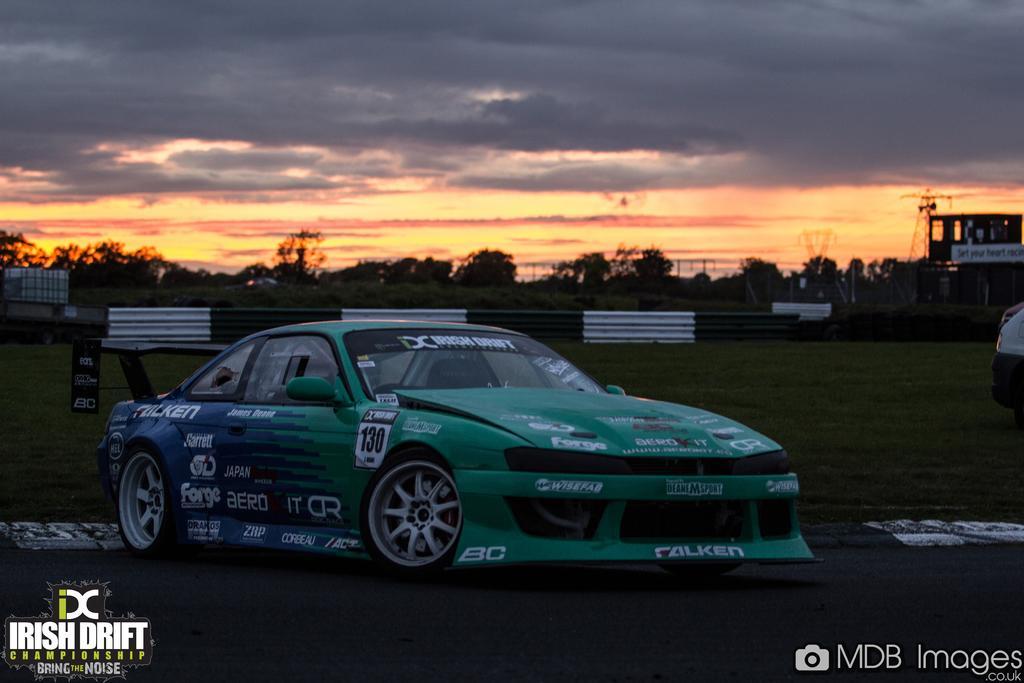Can you describe this image briefly? As we can see in the image there is cat, grass, building, trees, sky and clouds. 